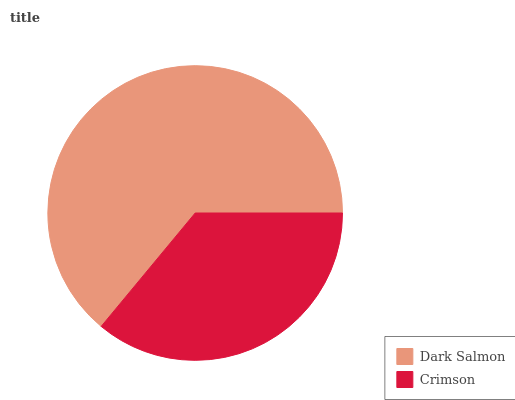Is Crimson the minimum?
Answer yes or no. Yes. Is Dark Salmon the maximum?
Answer yes or no. Yes. Is Crimson the maximum?
Answer yes or no. No. Is Dark Salmon greater than Crimson?
Answer yes or no. Yes. Is Crimson less than Dark Salmon?
Answer yes or no. Yes. Is Crimson greater than Dark Salmon?
Answer yes or no. No. Is Dark Salmon less than Crimson?
Answer yes or no. No. Is Dark Salmon the high median?
Answer yes or no. Yes. Is Crimson the low median?
Answer yes or no. Yes. Is Crimson the high median?
Answer yes or no. No. Is Dark Salmon the low median?
Answer yes or no. No. 